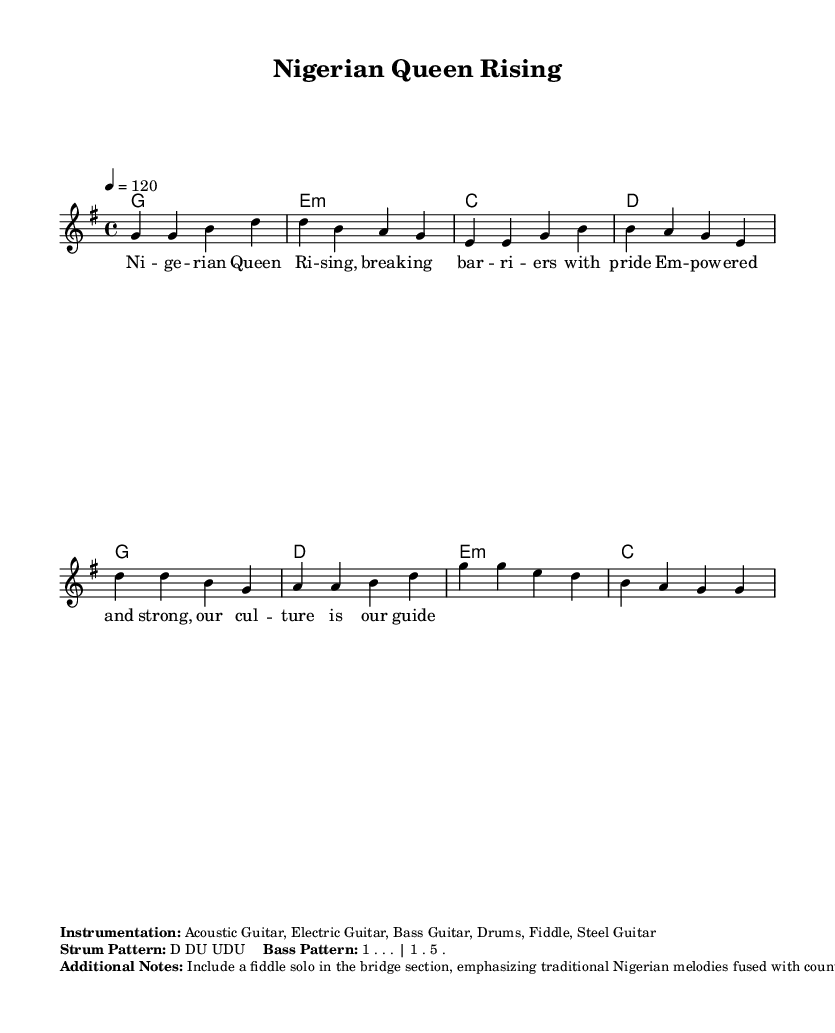What is the key signature of this music? The key signature is G major, which has one sharp (F#). This is indicated at the beginning of the score.
Answer: G major What is the time signature of this piece? The time signature is 4/4, which means there are four beats in each measure and the quarter note gets one beat. This information is found both on the first line of the score and within the rhythmic structure of the music.
Answer: 4/4 What is the tempo marking given? The tempo marking is indicated as "4 = 120," which means the quarter note is to be played at a pace of 120 beats per minute. This specifies the speed at which the piece should be performed.
Answer: 120 How many measures are in the verse section? The verse section consists of four measures, which can be verified by counting the measures shown in the melody and harmonies sections designated as verse.
Answer: 4 What instrumentation is specified for this piece? The instrumentation listed includes Acoustic Guitar, Electric Guitar, Bass Guitar, Drums, Fiddle, and Steel Guitar. This information is provided in the markup section after the score.
Answer: Acoustic Guitar, Electric Guitar, Bass Guitar, Drums, Fiddle, Steel Guitar What is the strum pattern indicated for the guitars? The strum pattern is described as D DU UDU. This pattern specifies the strumming technique to be used and is noted in the additional information provided after the music.
Answer: D DU UDU What additional element is suggested to include in the bridge section? A fiddle solo emphasizing traditional Nigerian melodies fused with country rock style is suggested for the bridge section. This indicates a specific cultural influence intended to enrich the piece.
Answer: Fiddle solo 